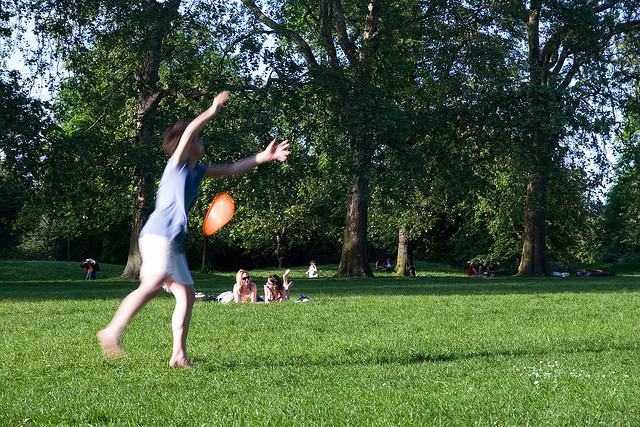Is this person old?
Quick response, please. No. How many girls are in the background?
Write a very short answer. 2. What is being thrown?
Quick response, please. Frisbee. 